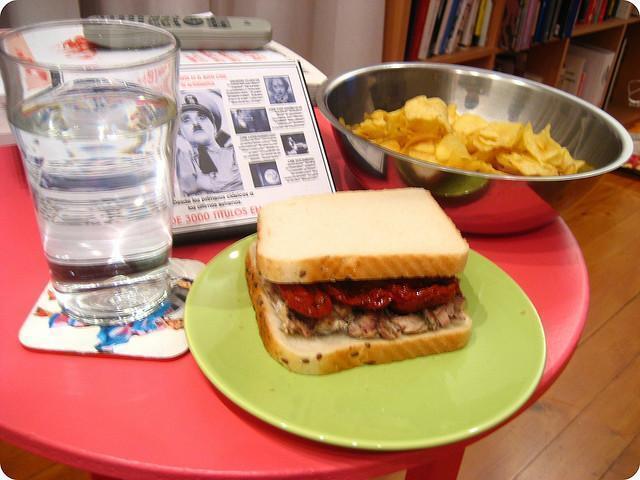What side dish is to be enjoyed with this sandwich?
Answer the question by selecting the correct answer among the 4 following choices and explain your choice with a short sentence. The answer should be formatted with the following format: `Answer: choice
Rationale: rationale.`
Options: Pears, potato chips, bacon, apples. Answer: potato chips.
Rationale: The dish is potato chips. 